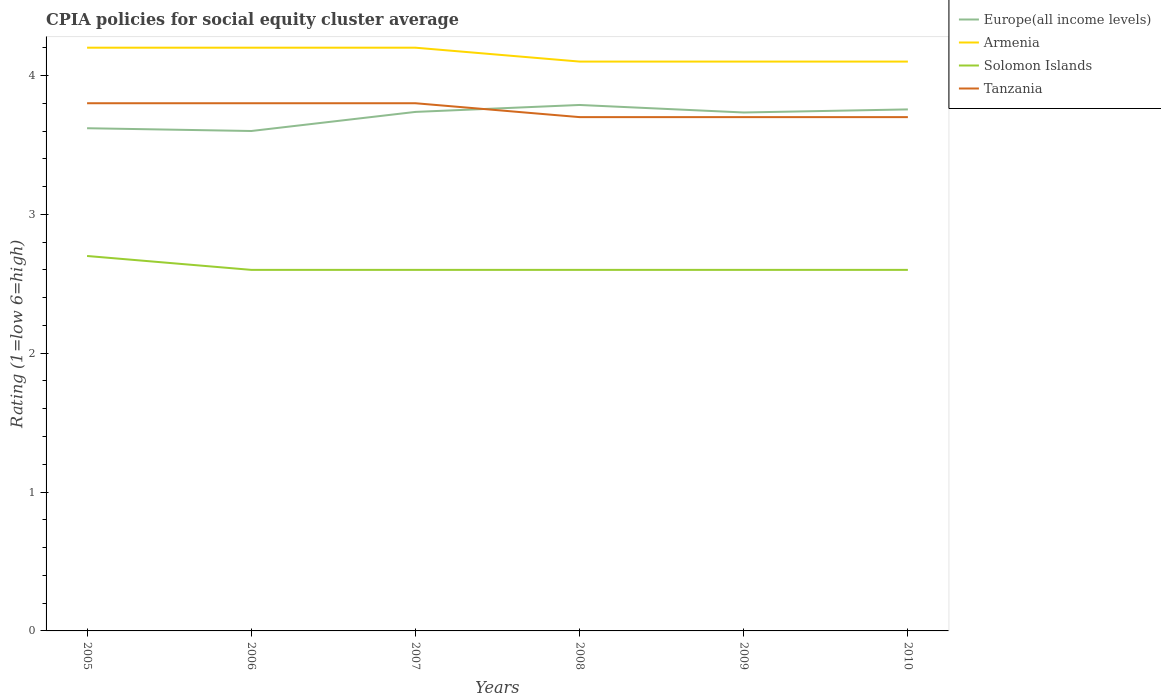Does the line corresponding to Tanzania intersect with the line corresponding to Armenia?
Make the answer very short. No. Is the number of lines equal to the number of legend labels?
Provide a succinct answer. Yes. Across all years, what is the maximum CPIA rating in Solomon Islands?
Make the answer very short. 2.6. In which year was the CPIA rating in Tanzania maximum?
Provide a succinct answer. 2008. What is the total CPIA rating in Solomon Islands in the graph?
Provide a succinct answer. 0. What is the difference between the highest and the second highest CPIA rating in Armenia?
Your response must be concise. 0.1. Is the CPIA rating in Armenia strictly greater than the CPIA rating in Europe(all income levels) over the years?
Your answer should be compact. No. How many years are there in the graph?
Offer a terse response. 6. Are the values on the major ticks of Y-axis written in scientific E-notation?
Your answer should be very brief. No. Does the graph contain any zero values?
Ensure brevity in your answer.  No. Does the graph contain grids?
Make the answer very short. No. What is the title of the graph?
Give a very brief answer. CPIA policies for social equity cluster average. What is the label or title of the Y-axis?
Give a very brief answer. Rating (1=low 6=high). What is the Rating (1=low 6=high) in Europe(all income levels) in 2005?
Your answer should be compact. 3.62. What is the Rating (1=low 6=high) in Armenia in 2005?
Ensure brevity in your answer.  4.2. What is the Rating (1=low 6=high) in Armenia in 2006?
Your answer should be compact. 4.2. What is the Rating (1=low 6=high) in Europe(all income levels) in 2007?
Provide a succinct answer. 3.74. What is the Rating (1=low 6=high) of Tanzania in 2007?
Offer a terse response. 3.8. What is the Rating (1=low 6=high) in Europe(all income levels) in 2008?
Make the answer very short. 3.79. What is the Rating (1=low 6=high) of Europe(all income levels) in 2009?
Your answer should be very brief. 3.73. What is the Rating (1=low 6=high) of Solomon Islands in 2009?
Offer a very short reply. 2.6. What is the Rating (1=low 6=high) of Tanzania in 2009?
Ensure brevity in your answer.  3.7. What is the Rating (1=low 6=high) of Europe(all income levels) in 2010?
Provide a short and direct response. 3.76. What is the Rating (1=low 6=high) in Armenia in 2010?
Give a very brief answer. 4.1. Across all years, what is the maximum Rating (1=low 6=high) in Europe(all income levels)?
Your answer should be very brief. 3.79. Across all years, what is the maximum Rating (1=low 6=high) in Solomon Islands?
Your answer should be very brief. 2.7. Across all years, what is the minimum Rating (1=low 6=high) in Tanzania?
Your answer should be compact. 3.7. What is the total Rating (1=low 6=high) of Europe(all income levels) in the graph?
Provide a succinct answer. 22.23. What is the total Rating (1=low 6=high) of Armenia in the graph?
Offer a very short reply. 24.9. What is the total Rating (1=low 6=high) of Tanzania in the graph?
Provide a succinct answer. 22.5. What is the difference between the Rating (1=low 6=high) of Armenia in 2005 and that in 2006?
Ensure brevity in your answer.  0. What is the difference between the Rating (1=low 6=high) of Solomon Islands in 2005 and that in 2006?
Offer a terse response. 0.1. What is the difference between the Rating (1=low 6=high) in Europe(all income levels) in 2005 and that in 2007?
Give a very brief answer. -0.12. What is the difference between the Rating (1=low 6=high) of Solomon Islands in 2005 and that in 2007?
Give a very brief answer. 0.1. What is the difference between the Rating (1=low 6=high) in Tanzania in 2005 and that in 2007?
Ensure brevity in your answer.  0. What is the difference between the Rating (1=low 6=high) of Europe(all income levels) in 2005 and that in 2008?
Your answer should be compact. -0.17. What is the difference between the Rating (1=low 6=high) in Tanzania in 2005 and that in 2008?
Your response must be concise. 0.1. What is the difference between the Rating (1=low 6=high) in Europe(all income levels) in 2005 and that in 2009?
Make the answer very short. -0.11. What is the difference between the Rating (1=low 6=high) in Armenia in 2005 and that in 2009?
Your answer should be compact. 0.1. What is the difference between the Rating (1=low 6=high) of Europe(all income levels) in 2005 and that in 2010?
Provide a succinct answer. -0.14. What is the difference between the Rating (1=low 6=high) of Tanzania in 2005 and that in 2010?
Offer a very short reply. 0.1. What is the difference between the Rating (1=low 6=high) of Europe(all income levels) in 2006 and that in 2007?
Offer a terse response. -0.14. What is the difference between the Rating (1=low 6=high) in Solomon Islands in 2006 and that in 2007?
Your response must be concise. 0. What is the difference between the Rating (1=low 6=high) of Europe(all income levels) in 2006 and that in 2008?
Your response must be concise. -0.19. What is the difference between the Rating (1=low 6=high) of Europe(all income levels) in 2006 and that in 2009?
Provide a short and direct response. -0.13. What is the difference between the Rating (1=low 6=high) in Armenia in 2006 and that in 2009?
Your answer should be very brief. 0.1. What is the difference between the Rating (1=low 6=high) of Europe(all income levels) in 2006 and that in 2010?
Your answer should be compact. -0.16. What is the difference between the Rating (1=low 6=high) in Tanzania in 2007 and that in 2008?
Offer a very short reply. 0.1. What is the difference between the Rating (1=low 6=high) of Europe(all income levels) in 2007 and that in 2009?
Your answer should be very brief. 0. What is the difference between the Rating (1=low 6=high) in Solomon Islands in 2007 and that in 2009?
Your response must be concise. 0. What is the difference between the Rating (1=low 6=high) of Europe(all income levels) in 2007 and that in 2010?
Keep it short and to the point. -0.02. What is the difference between the Rating (1=low 6=high) of Solomon Islands in 2007 and that in 2010?
Give a very brief answer. 0. What is the difference between the Rating (1=low 6=high) of Tanzania in 2007 and that in 2010?
Provide a succinct answer. 0.1. What is the difference between the Rating (1=low 6=high) of Europe(all income levels) in 2008 and that in 2009?
Provide a short and direct response. 0.05. What is the difference between the Rating (1=low 6=high) of Europe(all income levels) in 2008 and that in 2010?
Make the answer very short. 0.03. What is the difference between the Rating (1=low 6=high) of Tanzania in 2008 and that in 2010?
Provide a short and direct response. 0. What is the difference between the Rating (1=low 6=high) of Europe(all income levels) in 2009 and that in 2010?
Make the answer very short. -0.02. What is the difference between the Rating (1=low 6=high) in Europe(all income levels) in 2005 and the Rating (1=low 6=high) in Armenia in 2006?
Provide a succinct answer. -0.58. What is the difference between the Rating (1=low 6=high) of Europe(all income levels) in 2005 and the Rating (1=low 6=high) of Tanzania in 2006?
Provide a short and direct response. -0.18. What is the difference between the Rating (1=low 6=high) of Armenia in 2005 and the Rating (1=low 6=high) of Solomon Islands in 2006?
Give a very brief answer. 1.6. What is the difference between the Rating (1=low 6=high) of Europe(all income levels) in 2005 and the Rating (1=low 6=high) of Armenia in 2007?
Keep it short and to the point. -0.58. What is the difference between the Rating (1=low 6=high) of Europe(all income levels) in 2005 and the Rating (1=low 6=high) of Solomon Islands in 2007?
Ensure brevity in your answer.  1.02. What is the difference between the Rating (1=low 6=high) of Europe(all income levels) in 2005 and the Rating (1=low 6=high) of Tanzania in 2007?
Offer a terse response. -0.18. What is the difference between the Rating (1=low 6=high) in Armenia in 2005 and the Rating (1=low 6=high) in Solomon Islands in 2007?
Give a very brief answer. 1.6. What is the difference between the Rating (1=low 6=high) in Europe(all income levels) in 2005 and the Rating (1=low 6=high) in Armenia in 2008?
Provide a succinct answer. -0.48. What is the difference between the Rating (1=low 6=high) of Europe(all income levels) in 2005 and the Rating (1=low 6=high) of Solomon Islands in 2008?
Provide a succinct answer. 1.02. What is the difference between the Rating (1=low 6=high) in Europe(all income levels) in 2005 and the Rating (1=low 6=high) in Tanzania in 2008?
Keep it short and to the point. -0.08. What is the difference between the Rating (1=low 6=high) of Armenia in 2005 and the Rating (1=low 6=high) of Solomon Islands in 2008?
Offer a terse response. 1.6. What is the difference between the Rating (1=low 6=high) in Solomon Islands in 2005 and the Rating (1=low 6=high) in Tanzania in 2008?
Provide a short and direct response. -1. What is the difference between the Rating (1=low 6=high) in Europe(all income levels) in 2005 and the Rating (1=low 6=high) in Armenia in 2009?
Give a very brief answer. -0.48. What is the difference between the Rating (1=low 6=high) of Europe(all income levels) in 2005 and the Rating (1=low 6=high) of Tanzania in 2009?
Your answer should be very brief. -0.08. What is the difference between the Rating (1=low 6=high) of Armenia in 2005 and the Rating (1=low 6=high) of Solomon Islands in 2009?
Provide a succinct answer. 1.6. What is the difference between the Rating (1=low 6=high) in Armenia in 2005 and the Rating (1=low 6=high) in Tanzania in 2009?
Ensure brevity in your answer.  0.5. What is the difference between the Rating (1=low 6=high) in Solomon Islands in 2005 and the Rating (1=low 6=high) in Tanzania in 2009?
Ensure brevity in your answer.  -1. What is the difference between the Rating (1=low 6=high) of Europe(all income levels) in 2005 and the Rating (1=low 6=high) of Armenia in 2010?
Your answer should be very brief. -0.48. What is the difference between the Rating (1=low 6=high) of Europe(all income levels) in 2005 and the Rating (1=low 6=high) of Solomon Islands in 2010?
Your answer should be compact. 1.02. What is the difference between the Rating (1=low 6=high) in Europe(all income levels) in 2005 and the Rating (1=low 6=high) in Tanzania in 2010?
Offer a terse response. -0.08. What is the difference between the Rating (1=low 6=high) of Armenia in 2005 and the Rating (1=low 6=high) of Solomon Islands in 2010?
Make the answer very short. 1.6. What is the difference between the Rating (1=low 6=high) in Armenia in 2005 and the Rating (1=low 6=high) in Tanzania in 2010?
Keep it short and to the point. 0.5. What is the difference between the Rating (1=low 6=high) in Europe(all income levels) in 2006 and the Rating (1=low 6=high) in Solomon Islands in 2007?
Your answer should be very brief. 1. What is the difference between the Rating (1=low 6=high) of Armenia in 2006 and the Rating (1=low 6=high) of Solomon Islands in 2007?
Give a very brief answer. 1.6. What is the difference between the Rating (1=low 6=high) in Armenia in 2006 and the Rating (1=low 6=high) in Tanzania in 2007?
Your answer should be compact. 0.4. What is the difference between the Rating (1=low 6=high) in Europe(all income levels) in 2006 and the Rating (1=low 6=high) in Armenia in 2008?
Offer a terse response. -0.5. What is the difference between the Rating (1=low 6=high) of Europe(all income levels) in 2006 and the Rating (1=low 6=high) of Tanzania in 2008?
Your answer should be compact. -0.1. What is the difference between the Rating (1=low 6=high) in Armenia in 2006 and the Rating (1=low 6=high) in Solomon Islands in 2008?
Provide a short and direct response. 1.6. What is the difference between the Rating (1=low 6=high) of Europe(all income levels) in 2006 and the Rating (1=low 6=high) of Solomon Islands in 2009?
Provide a short and direct response. 1. What is the difference between the Rating (1=low 6=high) in Europe(all income levels) in 2006 and the Rating (1=low 6=high) in Tanzania in 2009?
Your answer should be very brief. -0.1. What is the difference between the Rating (1=low 6=high) in Armenia in 2006 and the Rating (1=low 6=high) in Tanzania in 2009?
Your response must be concise. 0.5. What is the difference between the Rating (1=low 6=high) of Europe(all income levels) in 2006 and the Rating (1=low 6=high) of Armenia in 2010?
Make the answer very short. -0.5. What is the difference between the Rating (1=low 6=high) in Europe(all income levels) in 2006 and the Rating (1=low 6=high) in Tanzania in 2010?
Ensure brevity in your answer.  -0.1. What is the difference between the Rating (1=low 6=high) in Armenia in 2006 and the Rating (1=low 6=high) in Solomon Islands in 2010?
Your answer should be compact. 1.6. What is the difference between the Rating (1=low 6=high) in Solomon Islands in 2006 and the Rating (1=low 6=high) in Tanzania in 2010?
Ensure brevity in your answer.  -1.1. What is the difference between the Rating (1=low 6=high) of Europe(all income levels) in 2007 and the Rating (1=low 6=high) of Armenia in 2008?
Ensure brevity in your answer.  -0.36. What is the difference between the Rating (1=low 6=high) in Europe(all income levels) in 2007 and the Rating (1=low 6=high) in Solomon Islands in 2008?
Offer a terse response. 1.14. What is the difference between the Rating (1=low 6=high) of Europe(all income levels) in 2007 and the Rating (1=low 6=high) of Tanzania in 2008?
Provide a short and direct response. 0.04. What is the difference between the Rating (1=low 6=high) in Solomon Islands in 2007 and the Rating (1=low 6=high) in Tanzania in 2008?
Offer a very short reply. -1.1. What is the difference between the Rating (1=low 6=high) of Europe(all income levels) in 2007 and the Rating (1=low 6=high) of Armenia in 2009?
Your answer should be compact. -0.36. What is the difference between the Rating (1=low 6=high) of Europe(all income levels) in 2007 and the Rating (1=low 6=high) of Solomon Islands in 2009?
Provide a succinct answer. 1.14. What is the difference between the Rating (1=low 6=high) of Europe(all income levels) in 2007 and the Rating (1=low 6=high) of Tanzania in 2009?
Keep it short and to the point. 0.04. What is the difference between the Rating (1=low 6=high) of Armenia in 2007 and the Rating (1=low 6=high) of Solomon Islands in 2009?
Keep it short and to the point. 1.6. What is the difference between the Rating (1=low 6=high) of Armenia in 2007 and the Rating (1=low 6=high) of Tanzania in 2009?
Your response must be concise. 0.5. What is the difference between the Rating (1=low 6=high) of Europe(all income levels) in 2007 and the Rating (1=low 6=high) of Armenia in 2010?
Ensure brevity in your answer.  -0.36. What is the difference between the Rating (1=low 6=high) in Europe(all income levels) in 2007 and the Rating (1=low 6=high) in Solomon Islands in 2010?
Your answer should be very brief. 1.14. What is the difference between the Rating (1=low 6=high) in Europe(all income levels) in 2007 and the Rating (1=low 6=high) in Tanzania in 2010?
Give a very brief answer. 0.04. What is the difference between the Rating (1=low 6=high) of Armenia in 2007 and the Rating (1=low 6=high) of Solomon Islands in 2010?
Your answer should be very brief. 1.6. What is the difference between the Rating (1=low 6=high) in Armenia in 2007 and the Rating (1=low 6=high) in Tanzania in 2010?
Your response must be concise. 0.5. What is the difference between the Rating (1=low 6=high) in Europe(all income levels) in 2008 and the Rating (1=low 6=high) in Armenia in 2009?
Offer a very short reply. -0.31. What is the difference between the Rating (1=low 6=high) of Europe(all income levels) in 2008 and the Rating (1=low 6=high) of Solomon Islands in 2009?
Ensure brevity in your answer.  1.19. What is the difference between the Rating (1=low 6=high) in Europe(all income levels) in 2008 and the Rating (1=low 6=high) in Tanzania in 2009?
Offer a very short reply. 0.09. What is the difference between the Rating (1=low 6=high) in Solomon Islands in 2008 and the Rating (1=low 6=high) in Tanzania in 2009?
Provide a succinct answer. -1.1. What is the difference between the Rating (1=low 6=high) of Europe(all income levels) in 2008 and the Rating (1=low 6=high) of Armenia in 2010?
Give a very brief answer. -0.31. What is the difference between the Rating (1=low 6=high) of Europe(all income levels) in 2008 and the Rating (1=low 6=high) of Solomon Islands in 2010?
Your response must be concise. 1.19. What is the difference between the Rating (1=low 6=high) in Europe(all income levels) in 2008 and the Rating (1=low 6=high) in Tanzania in 2010?
Your answer should be very brief. 0.09. What is the difference between the Rating (1=low 6=high) in Armenia in 2008 and the Rating (1=low 6=high) in Solomon Islands in 2010?
Your answer should be very brief. 1.5. What is the difference between the Rating (1=low 6=high) of Solomon Islands in 2008 and the Rating (1=low 6=high) of Tanzania in 2010?
Provide a succinct answer. -1.1. What is the difference between the Rating (1=low 6=high) of Europe(all income levels) in 2009 and the Rating (1=low 6=high) of Armenia in 2010?
Your response must be concise. -0.37. What is the difference between the Rating (1=low 6=high) in Europe(all income levels) in 2009 and the Rating (1=low 6=high) in Solomon Islands in 2010?
Your answer should be compact. 1.13. What is the difference between the Rating (1=low 6=high) in Armenia in 2009 and the Rating (1=low 6=high) in Solomon Islands in 2010?
Make the answer very short. 1.5. What is the difference between the Rating (1=low 6=high) of Armenia in 2009 and the Rating (1=low 6=high) of Tanzania in 2010?
Offer a terse response. 0.4. What is the difference between the Rating (1=low 6=high) in Solomon Islands in 2009 and the Rating (1=low 6=high) in Tanzania in 2010?
Make the answer very short. -1.1. What is the average Rating (1=low 6=high) of Europe(all income levels) per year?
Provide a short and direct response. 3.71. What is the average Rating (1=low 6=high) of Armenia per year?
Your answer should be compact. 4.15. What is the average Rating (1=low 6=high) of Solomon Islands per year?
Provide a succinct answer. 2.62. What is the average Rating (1=low 6=high) of Tanzania per year?
Provide a succinct answer. 3.75. In the year 2005, what is the difference between the Rating (1=low 6=high) of Europe(all income levels) and Rating (1=low 6=high) of Armenia?
Offer a terse response. -0.58. In the year 2005, what is the difference between the Rating (1=low 6=high) in Europe(all income levels) and Rating (1=low 6=high) in Tanzania?
Your answer should be very brief. -0.18. In the year 2005, what is the difference between the Rating (1=low 6=high) of Solomon Islands and Rating (1=low 6=high) of Tanzania?
Offer a very short reply. -1.1. In the year 2006, what is the difference between the Rating (1=low 6=high) of Europe(all income levels) and Rating (1=low 6=high) of Armenia?
Provide a succinct answer. -0.6. In the year 2006, what is the difference between the Rating (1=low 6=high) in Europe(all income levels) and Rating (1=low 6=high) in Tanzania?
Your answer should be very brief. -0.2. In the year 2006, what is the difference between the Rating (1=low 6=high) in Armenia and Rating (1=low 6=high) in Solomon Islands?
Offer a terse response. 1.6. In the year 2006, what is the difference between the Rating (1=low 6=high) in Solomon Islands and Rating (1=low 6=high) in Tanzania?
Your answer should be very brief. -1.2. In the year 2007, what is the difference between the Rating (1=low 6=high) in Europe(all income levels) and Rating (1=low 6=high) in Armenia?
Give a very brief answer. -0.46. In the year 2007, what is the difference between the Rating (1=low 6=high) of Europe(all income levels) and Rating (1=low 6=high) of Solomon Islands?
Offer a terse response. 1.14. In the year 2007, what is the difference between the Rating (1=low 6=high) of Europe(all income levels) and Rating (1=low 6=high) of Tanzania?
Your answer should be compact. -0.06. In the year 2007, what is the difference between the Rating (1=low 6=high) of Armenia and Rating (1=low 6=high) of Solomon Islands?
Your answer should be compact. 1.6. In the year 2007, what is the difference between the Rating (1=low 6=high) in Armenia and Rating (1=low 6=high) in Tanzania?
Provide a short and direct response. 0.4. In the year 2008, what is the difference between the Rating (1=low 6=high) of Europe(all income levels) and Rating (1=low 6=high) of Armenia?
Your response must be concise. -0.31. In the year 2008, what is the difference between the Rating (1=low 6=high) of Europe(all income levels) and Rating (1=low 6=high) of Solomon Islands?
Ensure brevity in your answer.  1.19. In the year 2008, what is the difference between the Rating (1=low 6=high) of Europe(all income levels) and Rating (1=low 6=high) of Tanzania?
Make the answer very short. 0.09. In the year 2008, what is the difference between the Rating (1=low 6=high) in Armenia and Rating (1=low 6=high) in Solomon Islands?
Offer a terse response. 1.5. In the year 2008, what is the difference between the Rating (1=low 6=high) in Solomon Islands and Rating (1=low 6=high) in Tanzania?
Your response must be concise. -1.1. In the year 2009, what is the difference between the Rating (1=low 6=high) of Europe(all income levels) and Rating (1=low 6=high) of Armenia?
Provide a short and direct response. -0.37. In the year 2009, what is the difference between the Rating (1=low 6=high) of Europe(all income levels) and Rating (1=low 6=high) of Solomon Islands?
Keep it short and to the point. 1.13. In the year 2009, what is the difference between the Rating (1=low 6=high) of Europe(all income levels) and Rating (1=low 6=high) of Tanzania?
Give a very brief answer. 0.03. In the year 2009, what is the difference between the Rating (1=low 6=high) in Armenia and Rating (1=low 6=high) in Solomon Islands?
Ensure brevity in your answer.  1.5. In the year 2009, what is the difference between the Rating (1=low 6=high) of Armenia and Rating (1=low 6=high) of Tanzania?
Make the answer very short. 0.4. In the year 2010, what is the difference between the Rating (1=low 6=high) in Europe(all income levels) and Rating (1=low 6=high) in Armenia?
Your answer should be compact. -0.34. In the year 2010, what is the difference between the Rating (1=low 6=high) in Europe(all income levels) and Rating (1=low 6=high) in Solomon Islands?
Your answer should be very brief. 1.16. In the year 2010, what is the difference between the Rating (1=low 6=high) of Europe(all income levels) and Rating (1=low 6=high) of Tanzania?
Your answer should be very brief. 0.06. In the year 2010, what is the difference between the Rating (1=low 6=high) of Armenia and Rating (1=low 6=high) of Tanzania?
Ensure brevity in your answer.  0.4. In the year 2010, what is the difference between the Rating (1=low 6=high) in Solomon Islands and Rating (1=low 6=high) in Tanzania?
Your response must be concise. -1.1. What is the ratio of the Rating (1=low 6=high) in Europe(all income levels) in 2005 to that in 2006?
Provide a short and direct response. 1.01. What is the ratio of the Rating (1=low 6=high) of Armenia in 2005 to that in 2006?
Ensure brevity in your answer.  1. What is the ratio of the Rating (1=low 6=high) in Solomon Islands in 2005 to that in 2006?
Keep it short and to the point. 1.04. What is the ratio of the Rating (1=low 6=high) in Europe(all income levels) in 2005 to that in 2007?
Offer a terse response. 0.97. What is the ratio of the Rating (1=low 6=high) in Solomon Islands in 2005 to that in 2007?
Offer a very short reply. 1.04. What is the ratio of the Rating (1=low 6=high) in Europe(all income levels) in 2005 to that in 2008?
Ensure brevity in your answer.  0.96. What is the ratio of the Rating (1=low 6=high) in Armenia in 2005 to that in 2008?
Offer a very short reply. 1.02. What is the ratio of the Rating (1=low 6=high) in Solomon Islands in 2005 to that in 2008?
Your answer should be compact. 1.04. What is the ratio of the Rating (1=low 6=high) in Europe(all income levels) in 2005 to that in 2009?
Make the answer very short. 0.97. What is the ratio of the Rating (1=low 6=high) in Armenia in 2005 to that in 2009?
Provide a short and direct response. 1.02. What is the ratio of the Rating (1=low 6=high) of Solomon Islands in 2005 to that in 2009?
Keep it short and to the point. 1.04. What is the ratio of the Rating (1=low 6=high) in Europe(all income levels) in 2005 to that in 2010?
Provide a succinct answer. 0.96. What is the ratio of the Rating (1=low 6=high) in Armenia in 2005 to that in 2010?
Your answer should be compact. 1.02. What is the ratio of the Rating (1=low 6=high) of Solomon Islands in 2005 to that in 2010?
Provide a short and direct response. 1.04. What is the ratio of the Rating (1=low 6=high) in Europe(all income levels) in 2006 to that in 2007?
Your answer should be compact. 0.96. What is the ratio of the Rating (1=low 6=high) in Europe(all income levels) in 2006 to that in 2008?
Provide a short and direct response. 0.95. What is the ratio of the Rating (1=low 6=high) of Armenia in 2006 to that in 2008?
Provide a succinct answer. 1.02. What is the ratio of the Rating (1=low 6=high) in Europe(all income levels) in 2006 to that in 2009?
Your answer should be compact. 0.96. What is the ratio of the Rating (1=low 6=high) in Armenia in 2006 to that in 2009?
Give a very brief answer. 1.02. What is the ratio of the Rating (1=low 6=high) in Solomon Islands in 2006 to that in 2009?
Your answer should be compact. 1. What is the ratio of the Rating (1=low 6=high) of Europe(all income levels) in 2006 to that in 2010?
Provide a short and direct response. 0.96. What is the ratio of the Rating (1=low 6=high) in Armenia in 2006 to that in 2010?
Offer a terse response. 1.02. What is the ratio of the Rating (1=low 6=high) in Solomon Islands in 2006 to that in 2010?
Your answer should be very brief. 1. What is the ratio of the Rating (1=low 6=high) in Armenia in 2007 to that in 2008?
Provide a succinct answer. 1.02. What is the ratio of the Rating (1=low 6=high) in Armenia in 2007 to that in 2009?
Your response must be concise. 1.02. What is the ratio of the Rating (1=low 6=high) in Armenia in 2007 to that in 2010?
Make the answer very short. 1.02. What is the ratio of the Rating (1=low 6=high) of Solomon Islands in 2007 to that in 2010?
Offer a terse response. 1. What is the ratio of the Rating (1=low 6=high) in Europe(all income levels) in 2008 to that in 2009?
Your response must be concise. 1.01. What is the ratio of the Rating (1=low 6=high) of Armenia in 2008 to that in 2009?
Offer a terse response. 1. What is the ratio of the Rating (1=low 6=high) in Tanzania in 2008 to that in 2009?
Your response must be concise. 1. What is the ratio of the Rating (1=low 6=high) in Europe(all income levels) in 2008 to that in 2010?
Provide a succinct answer. 1.01. What is the ratio of the Rating (1=low 6=high) of Armenia in 2008 to that in 2010?
Provide a succinct answer. 1. What is the ratio of the Rating (1=low 6=high) of Solomon Islands in 2008 to that in 2010?
Keep it short and to the point. 1. What is the ratio of the Rating (1=low 6=high) in Tanzania in 2008 to that in 2010?
Keep it short and to the point. 1. What is the ratio of the Rating (1=low 6=high) of Europe(all income levels) in 2009 to that in 2010?
Your answer should be very brief. 0.99. What is the difference between the highest and the second highest Rating (1=low 6=high) in Europe(all income levels)?
Keep it short and to the point. 0.03. What is the difference between the highest and the second highest Rating (1=low 6=high) of Armenia?
Keep it short and to the point. 0. What is the difference between the highest and the second highest Rating (1=low 6=high) of Solomon Islands?
Your response must be concise. 0.1. What is the difference between the highest and the second highest Rating (1=low 6=high) in Tanzania?
Give a very brief answer. 0. What is the difference between the highest and the lowest Rating (1=low 6=high) in Europe(all income levels)?
Provide a succinct answer. 0.19. What is the difference between the highest and the lowest Rating (1=low 6=high) of Solomon Islands?
Your answer should be very brief. 0.1. What is the difference between the highest and the lowest Rating (1=low 6=high) of Tanzania?
Provide a succinct answer. 0.1. 